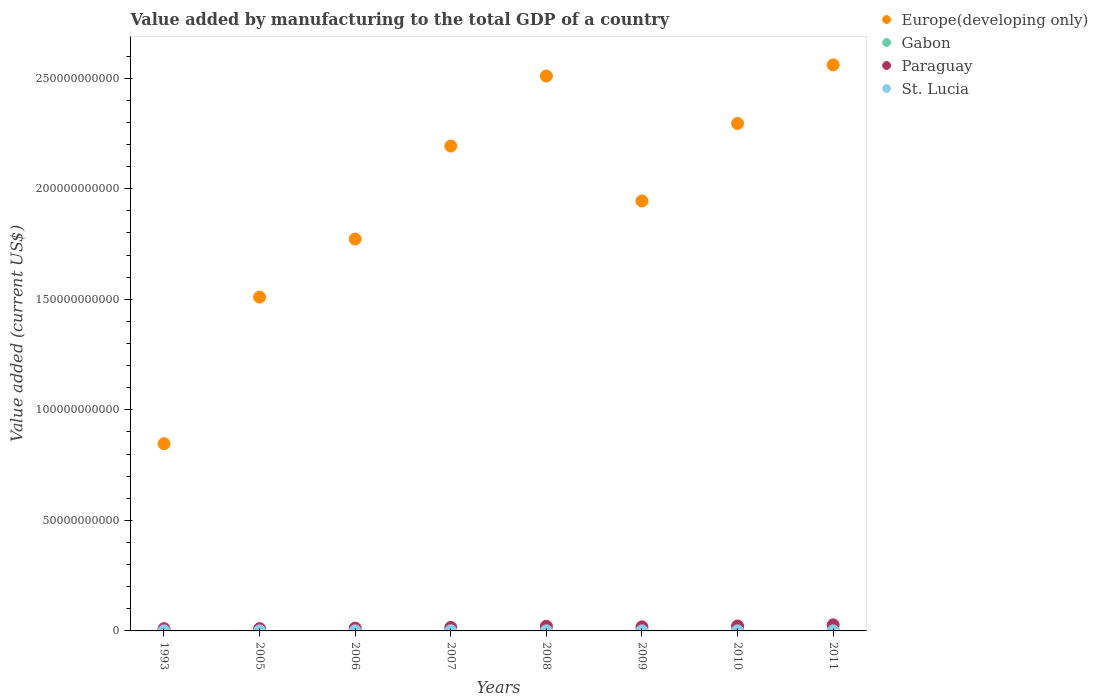How many different coloured dotlines are there?
Make the answer very short. 4. What is the value added by manufacturing to the total GDP in Europe(developing only) in 2006?
Your answer should be very brief. 1.77e+11. Across all years, what is the maximum value added by manufacturing to the total GDP in Paraguay?
Provide a succinct answer. 2.75e+09. Across all years, what is the minimum value added by manufacturing to the total GDP in Europe(developing only)?
Your answer should be compact. 8.47e+1. What is the total value added by manufacturing to the total GDP in Gabon in the graph?
Keep it short and to the point. 2.46e+09. What is the difference between the value added by manufacturing to the total GDP in Europe(developing only) in 1993 and that in 2006?
Offer a very short reply. -9.26e+1. What is the difference between the value added by manufacturing to the total GDP in Paraguay in 1993 and the value added by manufacturing to the total GDP in Gabon in 2009?
Offer a terse response. 6.67e+08. What is the average value added by manufacturing to the total GDP in Paraguay per year?
Ensure brevity in your answer.  1.73e+09. In the year 2011, what is the difference between the value added by manufacturing to the total GDP in Gabon and value added by manufacturing to the total GDP in St. Lucia?
Provide a succinct answer. 3.57e+08. What is the ratio of the value added by manufacturing to the total GDP in St. Lucia in 2006 to that in 2010?
Your response must be concise. 1.17. Is the value added by manufacturing to the total GDP in Gabon in 2006 less than that in 2007?
Your answer should be very brief. Yes. Is the difference between the value added by manufacturing to the total GDP in Gabon in 1993 and 2005 greater than the difference between the value added by manufacturing to the total GDP in St. Lucia in 1993 and 2005?
Your answer should be compact. Yes. What is the difference between the highest and the second highest value added by manufacturing to the total GDP in Europe(developing only)?
Provide a succinct answer. 5.05e+09. What is the difference between the highest and the lowest value added by manufacturing to the total GDP in Gabon?
Offer a very short reply. 1.70e+08. In how many years, is the value added by manufacturing to the total GDP in Paraguay greater than the average value added by manufacturing to the total GDP in Paraguay taken over all years?
Ensure brevity in your answer.  4. Is the sum of the value added by manufacturing to the total GDP in Paraguay in 1993 and 2011 greater than the maximum value added by manufacturing to the total GDP in Gabon across all years?
Ensure brevity in your answer.  Yes. Is it the case that in every year, the sum of the value added by manufacturing to the total GDP in Paraguay and value added by manufacturing to the total GDP in Europe(developing only)  is greater than the sum of value added by manufacturing to the total GDP in Gabon and value added by manufacturing to the total GDP in St. Lucia?
Make the answer very short. Yes. Does the value added by manufacturing to the total GDP in St. Lucia monotonically increase over the years?
Your answer should be compact. No. Is the value added by manufacturing to the total GDP in Europe(developing only) strictly less than the value added by manufacturing to the total GDP in Gabon over the years?
Ensure brevity in your answer.  No. How many dotlines are there?
Provide a succinct answer. 4. How many years are there in the graph?
Keep it short and to the point. 8. What is the difference between two consecutive major ticks on the Y-axis?
Offer a very short reply. 5.00e+1. Does the graph contain any zero values?
Offer a terse response. No. Does the graph contain grids?
Provide a short and direct response. No. Where does the legend appear in the graph?
Give a very brief answer. Top right. What is the title of the graph?
Offer a terse response. Value added by manufacturing to the total GDP of a country. Does "Sierra Leone" appear as one of the legend labels in the graph?
Your response must be concise. No. What is the label or title of the X-axis?
Offer a terse response. Years. What is the label or title of the Y-axis?
Provide a short and direct response. Value added (current US$). What is the Value added (current US$) of Europe(developing only) in 1993?
Offer a very short reply. 8.47e+1. What is the Value added (current US$) of Gabon in 1993?
Ensure brevity in your answer.  2.76e+08. What is the Value added (current US$) of Paraguay in 1993?
Offer a terse response. 1.01e+09. What is the Value added (current US$) in St. Lucia in 1993?
Your response must be concise. 3.07e+07. What is the Value added (current US$) of Europe(developing only) in 2005?
Provide a short and direct response. 1.51e+11. What is the Value added (current US$) in Gabon in 2005?
Your response must be concise. 2.28e+08. What is the Value added (current US$) of Paraguay in 2005?
Make the answer very short. 1.04e+09. What is the Value added (current US$) of St. Lucia in 2005?
Make the answer very short. 4.21e+07. What is the Value added (current US$) in Europe(developing only) in 2006?
Make the answer very short. 1.77e+11. What is the Value added (current US$) of Gabon in 2006?
Provide a succinct answer. 2.65e+08. What is the Value added (current US$) in Paraguay in 2006?
Give a very brief answer. 1.27e+09. What is the Value added (current US$) in St. Lucia in 2006?
Your answer should be very brief. 4.49e+07. What is the Value added (current US$) in Europe(developing only) in 2007?
Provide a succinct answer. 2.19e+11. What is the Value added (current US$) of Gabon in 2007?
Your response must be concise. 3.14e+08. What is the Value added (current US$) in Paraguay in 2007?
Your answer should be compact. 1.57e+09. What is the Value added (current US$) of St. Lucia in 2007?
Keep it short and to the point. 4.93e+07. What is the Value added (current US$) in Europe(developing only) in 2008?
Your answer should be compact. 2.51e+11. What is the Value added (current US$) of Gabon in 2008?
Your answer should be very brief. 3.51e+08. What is the Value added (current US$) of Paraguay in 2008?
Ensure brevity in your answer.  2.12e+09. What is the Value added (current US$) in St. Lucia in 2008?
Offer a terse response. 4.46e+07. What is the Value added (current US$) in Europe(developing only) in 2009?
Provide a succinct answer. 1.94e+11. What is the Value added (current US$) in Gabon in 2009?
Provide a short and direct response. 3.47e+08. What is the Value added (current US$) in Paraguay in 2009?
Ensure brevity in your answer.  1.85e+09. What is the Value added (current US$) of St. Lucia in 2009?
Offer a terse response. 4.00e+07. What is the Value added (current US$) of Europe(developing only) in 2010?
Give a very brief answer. 2.30e+11. What is the Value added (current US$) of Gabon in 2010?
Give a very brief answer. 2.79e+08. What is the Value added (current US$) in Paraguay in 2010?
Offer a terse response. 2.24e+09. What is the Value added (current US$) in St. Lucia in 2010?
Offer a terse response. 3.83e+07. What is the Value added (current US$) of Europe(developing only) in 2011?
Give a very brief answer. 2.56e+11. What is the Value added (current US$) in Gabon in 2011?
Your answer should be very brief. 3.98e+08. What is the Value added (current US$) of Paraguay in 2011?
Give a very brief answer. 2.75e+09. What is the Value added (current US$) of St. Lucia in 2011?
Make the answer very short. 4.11e+07. Across all years, what is the maximum Value added (current US$) in Europe(developing only)?
Your answer should be compact. 2.56e+11. Across all years, what is the maximum Value added (current US$) of Gabon?
Give a very brief answer. 3.98e+08. Across all years, what is the maximum Value added (current US$) in Paraguay?
Keep it short and to the point. 2.75e+09. Across all years, what is the maximum Value added (current US$) in St. Lucia?
Provide a short and direct response. 4.93e+07. Across all years, what is the minimum Value added (current US$) of Europe(developing only)?
Ensure brevity in your answer.  8.47e+1. Across all years, what is the minimum Value added (current US$) of Gabon?
Your response must be concise. 2.28e+08. Across all years, what is the minimum Value added (current US$) in Paraguay?
Give a very brief answer. 1.01e+09. Across all years, what is the minimum Value added (current US$) of St. Lucia?
Ensure brevity in your answer.  3.07e+07. What is the total Value added (current US$) in Europe(developing only) in the graph?
Your answer should be compact. 1.56e+12. What is the total Value added (current US$) in Gabon in the graph?
Your answer should be compact. 2.46e+09. What is the total Value added (current US$) of Paraguay in the graph?
Your answer should be compact. 1.38e+1. What is the total Value added (current US$) in St. Lucia in the graph?
Ensure brevity in your answer.  3.31e+08. What is the difference between the Value added (current US$) of Europe(developing only) in 1993 and that in 2005?
Your answer should be very brief. -6.63e+1. What is the difference between the Value added (current US$) of Gabon in 1993 and that in 2005?
Keep it short and to the point. 4.79e+07. What is the difference between the Value added (current US$) of Paraguay in 1993 and that in 2005?
Keep it short and to the point. -2.43e+07. What is the difference between the Value added (current US$) in St. Lucia in 1993 and that in 2005?
Make the answer very short. -1.14e+07. What is the difference between the Value added (current US$) of Europe(developing only) in 1993 and that in 2006?
Your answer should be very brief. -9.26e+1. What is the difference between the Value added (current US$) of Gabon in 1993 and that in 2006?
Your answer should be very brief. 1.08e+07. What is the difference between the Value added (current US$) of Paraguay in 1993 and that in 2006?
Provide a succinct answer. -2.53e+08. What is the difference between the Value added (current US$) in St. Lucia in 1993 and that in 2006?
Offer a terse response. -1.42e+07. What is the difference between the Value added (current US$) in Europe(developing only) in 1993 and that in 2007?
Provide a succinct answer. -1.35e+11. What is the difference between the Value added (current US$) in Gabon in 1993 and that in 2007?
Your answer should be very brief. -3.86e+07. What is the difference between the Value added (current US$) in Paraguay in 1993 and that in 2007?
Ensure brevity in your answer.  -5.56e+08. What is the difference between the Value added (current US$) of St. Lucia in 1993 and that in 2007?
Your answer should be compact. -1.85e+07. What is the difference between the Value added (current US$) in Europe(developing only) in 1993 and that in 2008?
Give a very brief answer. -1.66e+11. What is the difference between the Value added (current US$) in Gabon in 1993 and that in 2008?
Your answer should be very brief. -7.50e+07. What is the difference between the Value added (current US$) in Paraguay in 1993 and that in 2008?
Provide a short and direct response. -1.10e+09. What is the difference between the Value added (current US$) in St. Lucia in 1993 and that in 2008?
Provide a succinct answer. -1.39e+07. What is the difference between the Value added (current US$) of Europe(developing only) in 1993 and that in 2009?
Provide a succinct answer. -1.10e+11. What is the difference between the Value added (current US$) of Gabon in 1993 and that in 2009?
Provide a short and direct response. -7.19e+07. What is the difference between the Value added (current US$) in Paraguay in 1993 and that in 2009?
Make the answer very short. -8.36e+08. What is the difference between the Value added (current US$) of St. Lucia in 1993 and that in 2009?
Offer a very short reply. -9.31e+06. What is the difference between the Value added (current US$) in Europe(developing only) in 1993 and that in 2010?
Offer a terse response. -1.45e+11. What is the difference between the Value added (current US$) of Gabon in 1993 and that in 2010?
Your response must be concise. -3.63e+06. What is the difference between the Value added (current US$) of Paraguay in 1993 and that in 2010?
Offer a terse response. -1.23e+09. What is the difference between the Value added (current US$) in St. Lucia in 1993 and that in 2010?
Provide a succinct answer. -7.61e+06. What is the difference between the Value added (current US$) in Europe(developing only) in 1993 and that in 2011?
Give a very brief answer. -1.71e+11. What is the difference between the Value added (current US$) in Gabon in 1993 and that in 2011?
Provide a short and direct response. -1.22e+08. What is the difference between the Value added (current US$) of Paraguay in 1993 and that in 2011?
Provide a succinct answer. -1.74e+09. What is the difference between the Value added (current US$) of St. Lucia in 1993 and that in 2011?
Your answer should be very brief. -1.03e+07. What is the difference between the Value added (current US$) of Europe(developing only) in 2005 and that in 2006?
Your response must be concise. -2.63e+1. What is the difference between the Value added (current US$) in Gabon in 2005 and that in 2006?
Offer a very short reply. -3.71e+07. What is the difference between the Value added (current US$) in Paraguay in 2005 and that in 2006?
Ensure brevity in your answer.  -2.29e+08. What is the difference between the Value added (current US$) in St. Lucia in 2005 and that in 2006?
Give a very brief answer. -2.80e+06. What is the difference between the Value added (current US$) in Europe(developing only) in 2005 and that in 2007?
Give a very brief answer. -6.83e+1. What is the difference between the Value added (current US$) in Gabon in 2005 and that in 2007?
Provide a succinct answer. -8.66e+07. What is the difference between the Value added (current US$) in Paraguay in 2005 and that in 2007?
Ensure brevity in your answer.  -5.32e+08. What is the difference between the Value added (current US$) in St. Lucia in 2005 and that in 2007?
Offer a very short reply. -7.16e+06. What is the difference between the Value added (current US$) in Europe(developing only) in 2005 and that in 2008?
Offer a terse response. -1.00e+11. What is the difference between the Value added (current US$) in Gabon in 2005 and that in 2008?
Provide a short and direct response. -1.23e+08. What is the difference between the Value added (current US$) in Paraguay in 2005 and that in 2008?
Your response must be concise. -1.08e+09. What is the difference between the Value added (current US$) of St. Lucia in 2005 and that in 2008?
Your response must be concise. -2.50e+06. What is the difference between the Value added (current US$) of Europe(developing only) in 2005 and that in 2009?
Provide a short and direct response. -4.35e+1. What is the difference between the Value added (current US$) of Gabon in 2005 and that in 2009?
Your response must be concise. -1.20e+08. What is the difference between the Value added (current US$) of Paraguay in 2005 and that in 2009?
Make the answer very short. -8.11e+08. What is the difference between the Value added (current US$) in St. Lucia in 2005 and that in 2009?
Offer a very short reply. 2.07e+06. What is the difference between the Value added (current US$) of Europe(developing only) in 2005 and that in 2010?
Make the answer very short. -7.85e+1. What is the difference between the Value added (current US$) in Gabon in 2005 and that in 2010?
Keep it short and to the point. -5.16e+07. What is the difference between the Value added (current US$) of Paraguay in 2005 and that in 2010?
Ensure brevity in your answer.  -1.20e+09. What is the difference between the Value added (current US$) of St. Lucia in 2005 and that in 2010?
Make the answer very short. 3.77e+06. What is the difference between the Value added (current US$) of Europe(developing only) in 2005 and that in 2011?
Your response must be concise. -1.05e+11. What is the difference between the Value added (current US$) in Gabon in 2005 and that in 2011?
Your answer should be very brief. -1.70e+08. What is the difference between the Value added (current US$) of Paraguay in 2005 and that in 2011?
Give a very brief answer. -1.71e+09. What is the difference between the Value added (current US$) in St. Lucia in 2005 and that in 2011?
Your answer should be compact. 1.05e+06. What is the difference between the Value added (current US$) in Europe(developing only) in 2006 and that in 2007?
Your answer should be very brief. -4.21e+1. What is the difference between the Value added (current US$) in Gabon in 2006 and that in 2007?
Keep it short and to the point. -4.94e+07. What is the difference between the Value added (current US$) in Paraguay in 2006 and that in 2007?
Your answer should be very brief. -3.03e+08. What is the difference between the Value added (current US$) in St. Lucia in 2006 and that in 2007?
Keep it short and to the point. -4.36e+06. What is the difference between the Value added (current US$) of Europe(developing only) in 2006 and that in 2008?
Provide a short and direct response. -7.37e+1. What is the difference between the Value added (current US$) of Gabon in 2006 and that in 2008?
Offer a very short reply. -8.58e+07. What is the difference between the Value added (current US$) of Paraguay in 2006 and that in 2008?
Offer a very short reply. -8.51e+08. What is the difference between the Value added (current US$) in St. Lucia in 2006 and that in 2008?
Your response must be concise. 2.95e+05. What is the difference between the Value added (current US$) of Europe(developing only) in 2006 and that in 2009?
Your answer should be compact. -1.72e+1. What is the difference between the Value added (current US$) of Gabon in 2006 and that in 2009?
Your response must be concise. -8.27e+07. What is the difference between the Value added (current US$) in Paraguay in 2006 and that in 2009?
Make the answer very short. -5.83e+08. What is the difference between the Value added (current US$) in St. Lucia in 2006 and that in 2009?
Offer a very short reply. 4.86e+06. What is the difference between the Value added (current US$) of Europe(developing only) in 2006 and that in 2010?
Ensure brevity in your answer.  -5.23e+1. What is the difference between the Value added (current US$) of Gabon in 2006 and that in 2010?
Make the answer very short. -1.44e+07. What is the difference between the Value added (current US$) in Paraguay in 2006 and that in 2010?
Your answer should be compact. -9.72e+08. What is the difference between the Value added (current US$) in St. Lucia in 2006 and that in 2010?
Provide a succinct answer. 6.57e+06. What is the difference between the Value added (current US$) in Europe(developing only) in 2006 and that in 2011?
Provide a succinct answer. -7.88e+1. What is the difference between the Value added (current US$) in Gabon in 2006 and that in 2011?
Keep it short and to the point. -1.33e+08. What is the difference between the Value added (current US$) in Paraguay in 2006 and that in 2011?
Ensure brevity in your answer.  -1.48e+09. What is the difference between the Value added (current US$) of St. Lucia in 2006 and that in 2011?
Ensure brevity in your answer.  3.84e+06. What is the difference between the Value added (current US$) in Europe(developing only) in 2007 and that in 2008?
Provide a succinct answer. -3.17e+1. What is the difference between the Value added (current US$) of Gabon in 2007 and that in 2008?
Give a very brief answer. -3.64e+07. What is the difference between the Value added (current US$) of Paraguay in 2007 and that in 2008?
Your response must be concise. -5.48e+08. What is the difference between the Value added (current US$) of St. Lucia in 2007 and that in 2008?
Your response must be concise. 4.66e+06. What is the difference between the Value added (current US$) of Europe(developing only) in 2007 and that in 2009?
Your answer should be very brief. 2.48e+1. What is the difference between the Value added (current US$) of Gabon in 2007 and that in 2009?
Provide a short and direct response. -3.33e+07. What is the difference between the Value added (current US$) in Paraguay in 2007 and that in 2009?
Keep it short and to the point. -2.80e+08. What is the difference between the Value added (current US$) in St. Lucia in 2007 and that in 2009?
Make the answer very short. 9.22e+06. What is the difference between the Value added (current US$) in Europe(developing only) in 2007 and that in 2010?
Your response must be concise. -1.02e+1. What is the difference between the Value added (current US$) in Gabon in 2007 and that in 2010?
Give a very brief answer. 3.50e+07. What is the difference between the Value added (current US$) of Paraguay in 2007 and that in 2010?
Give a very brief answer. -6.70e+08. What is the difference between the Value added (current US$) of St. Lucia in 2007 and that in 2010?
Provide a short and direct response. 1.09e+07. What is the difference between the Value added (current US$) in Europe(developing only) in 2007 and that in 2011?
Make the answer very short. -3.67e+1. What is the difference between the Value added (current US$) of Gabon in 2007 and that in 2011?
Your response must be concise. -8.36e+07. What is the difference between the Value added (current US$) in Paraguay in 2007 and that in 2011?
Keep it short and to the point. -1.18e+09. What is the difference between the Value added (current US$) in St. Lucia in 2007 and that in 2011?
Your answer should be compact. 8.20e+06. What is the difference between the Value added (current US$) in Europe(developing only) in 2008 and that in 2009?
Offer a very short reply. 5.65e+1. What is the difference between the Value added (current US$) of Gabon in 2008 and that in 2009?
Provide a succinct answer. 3.14e+06. What is the difference between the Value added (current US$) in Paraguay in 2008 and that in 2009?
Give a very brief answer. 2.68e+08. What is the difference between the Value added (current US$) of St. Lucia in 2008 and that in 2009?
Provide a succinct answer. 4.57e+06. What is the difference between the Value added (current US$) of Europe(developing only) in 2008 and that in 2010?
Your answer should be compact. 2.15e+1. What is the difference between the Value added (current US$) of Gabon in 2008 and that in 2010?
Provide a short and direct response. 7.14e+07. What is the difference between the Value added (current US$) of Paraguay in 2008 and that in 2010?
Provide a short and direct response. -1.21e+08. What is the difference between the Value added (current US$) of St. Lucia in 2008 and that in 2010?
Keep it short and to the point. 6.27e+06. What is the difference between the Value added (current US$) of Europe(developing only) in 2008 and that in 2011?
Make the answer very short. -5.05e+09. What is the difference between the Value added (current US$) in Gabon in 2008 and that in 2011?
Ensure brevity in your answer.  -4.72e+07. What is the difference between the Value added (current US$) of Paraguay in 2008 and that in 2011?
Offer a terse response. -6.31e+08. What is the difference between the Value added (current US$) in St. Lucia in 2008 and that in 2011?
Ensure brevity in your answer.  3.55e+06. What is the difference between the Value added (current US$) in Europe(developing only) in 2009 and that in 2010?
Provide a succinct answer. -3.51e+1. What is the difference between the Value added (current US$) in Gabon in 2009 and that in 2010?
Your response must be concise. 6.83e+07. What is the difference between the Value added (current US$) in Paraguay in 2009 and that in 2010?
Keep it short and to the point. -3.90e+08. What is the difference between the Value added (current US$) in St. Lucia in 2009 and that in 2010?
Provide a short and direct response. 1.70e+06. What is the difference between the Value added (current US$) of Europe(developing only) in 2009 and that in 2011?
Make the answer very short. -6.16e+1. What is the difference between the Value added (current US$) of Gabon in 2009 and that in 2011?
Ensure brevity in your answer.  -5.03e+07. What is the difference between the Value added (current US$) of Paraguay in 2009 and that in 2011?
Offer a terse response. -8.99e+08. What is the difference between the Value added (current US$) of St. Lucia in 2009 and that in 2011?
Provide a short and direct response. -1.02e+06. What is the difference between the Value added (current US$) of Europe(developing only) in 2010 and that in 2011?
Give a very brief answer. -2.65e+1. What is the difference between the Value added (current US$) of Gabon in 2010 and that in 2011?
Offer a very short reply. -1.19e+08. What is the difference between the Value added (current US$) in Paraguay in 2010 and that in 2011?
Ensure brevity in your answer.  -5.10e+08. What is the difference between the Value added (current US$) of St. Lucia in 2010 and that in 2011?
Your answer should be compact. -2.72e+06. What is the difference between the Value added (current US$) of Europe(developing only) in 1993 and the Value added (current US$) of Gabon in 2005?
Offer a very short reply. 8.44e+1. What is the difference between the Value added (current US$) of Europe(developing only) in 1993 and the Value added (current US$) of Paraguay in 2005?
Your answer should be compact. 8.36e+1. What is the difference between the Value added (current US$) of Europe(developing only) in 1993 and the Value added (current US$) of St. Lucia in 2005?
Keep it short and to the point. 8.46e+1. What is the difference between the Value added (current US$) of Gabon in 1993 and the Value added (current US$) of Paraguay in 2005?
Provide a short and direct response. -7.63e+08. What is the difference between the Value added (current US$) of Gabon in 1993 and the Value added (current US$) of St. Lucia in 2005?
Make the answer very short. 2.33e+08. What is the difference between the Value added (current US$) of Paraguay in 1993 and the Value added (current US$) of St. Lucia in 2005?
Provide a succinct answer. 9.72e+08. What is the difference between the Value added (current US$) in Europe(developing only) in 1993 and the Value added (current US$) in Gabon in 2006?
Your answer should be very brief. 8.44e+1. What is the difference between the Value added (current US$) in Europe(developing only) in 1993 and the Value added (current US$) in Paraguay in 2006?
Ensure brevity in your answer.  8.34e+1. What is the difference between the Value added (current US$) in Europe(developing only) in 1993 and the Value added (current US$) in St. Lucia in 2006?
Keep it short and to the point. 8.46e+1. What is the difference between the Value added (current US$) of Gabon in 1993 and the Value added (current US$) of Paraguay in 2006?
Your answer should be very brief. -9.92e+08. What is the difference between the Value added (current US$) in Gabon in 1993 and the Value added (current US$) in St. Lucia in 2006?
Offer a very short reply. 2.31e+08. What is the difference between the Value added (current US$) of Paraguay in 1993 and the Value added (current US$) of St. Lucia in 2006?
Your answer should be compact. 9.69e+08. What is the difference between the Value added (current US$) of Europe(developing only) in 1993 and the Value added (current US$) of Gabon in 2007?
Make the answer very short. 8.44e+1. What is the difference between the Value added (current US$) in Europe(developing only) in 1993 and the Value added (current US$) in Paraguay in 2007?
Your answer should be compact. 8.31e+1. What is the difference between the Value added (current US$) in Europe(developing only) in 1993 and the Value added (current US$) in St. Lucia in 2007?
Offer a terse response. 8.46e+1. What is the difference between the Value added (current US$) of Gabon in 1993 and the Value added (current US$) of Paraguay in 2007?
Offer a very short reply. -1.29e+09. What is the difference between the Value added (current US$) in Gabon in 1993 and the Value added (current US$) in St. Lucia in 2007?
Your answer should be very brief. 2.26e+08. What is the difference between the Value added (current US$) in Paraguay in 1993 and the Value added (current US$) in St. Lucia in 2007?
Ensure brevity in your answer.  9.65e+08. What is the difference between the Value added (current US$) of Europe(developing only) in 1993 and the Value added (current US$) of Gabon in 2008?
Make the answer very short. 8.43e+1. What is the difference between the Value added (current US$) in Europe(developing only) in 1993 and the Value added (current US$) in Paraguay in 2008?
Offer a terse response. 8.26e+1. What is the difference between the Value added (current US$) of Europe(developing only) in 1993 and the Value added (current US$) of St. Lucia in 2008?
Provide a succinct answer. 8.46e+1. What is the difference between the Value added (current US$) in Gabon in 1993 and the Value added (current US$) in Paraguay in 2008?
Your answer should be compact. -1.84e+09. What is the difference between the Value added (current US$) of Gabon in 1993 and the Value added (current US$) of St. Lucia in 2008?
Your response must be concise. 2.31e+08. What is the difference between the Value added (current US$) in Paraguay in 1993 and the Value added (current US$) in St. Lucia in 2008?
Offer a very short reply. 9.69e+08. What is the difference between the Value added (current US$) in Europe(developing only) in 1993 and the Value added (current US$) in Gabon in 2009?
Provide a short and direct response. 8.43e+1. What is the difference between the Value added (current US$) of Europe(developing only) in 1993 and the Value added (current US$) of Paraguay in 2009?
Your answer should be compact. 8.28e+1. What is the difference between the Value added (current US$) in Europe(developing only) in 1993 and the Value added (current US$) in St. Lucia in 2009?
Offer a very short reply. 8.46e+1. What is the difference between the Value added (current US$) of Gabon in 1993 and the Value added (current US$) of Paraguay in 2009?
Offer a terse response. -1.57e+09. What is the difference between the Value added (current US$) of Gabon in 1993 and the Value added (current US$) of St. Lucia in 2009?
Offer a terse response. 2.35e+08. What is the difference between the Value added (current US$) of Paraguay in 1993 and the Value added (current US$) of St. Lucia in 2009?
Give a very brief answer. 9.74e+08. What is the difference between the Value added (current US$) of Europe(developing only) in 1993 and the Value added (current US$) of Gabon in 2010?
Offer a terse response. 8.44e+1. What is the difference between the Value added (current US$) in Europe(developing only) in 1993 and the Value added (current US$) in Paraguay in 2010?
Keep it short and to the point. 8.24e+1. What is the difference between the Value added (current US$) of Europe(developing only) in 1993 and the Value added (current US$) of St. Lucia in 2010?
Give a very brief answer. 8.46e+1. What is the difference between the Value added (current US$) in Gabon in 1993 and the Value added (current US$) in Paraguay in 2010?
Provide a short and direct response. -1.96e+09. What is the difference between the Value added (current US$) in Gabon in 1993 and the Value added (current US$) in St. Lucia in 2010?
Ensure brevity in your answer.  2.37e+08. What is the difference between the Value added (current US$) in Paraguay in 1993 and the Value added (current US$) in St. Lucia in 2010?
Provide a short and direct response. 9.76e+08. What is the difference between the Value added (current US$) in Europe(developing only) in 1993 and the Value added (current US$) in Gabon in 2011?
Your answer should be very brief. 8.43e+1. What is the difference between the Value added (current US$) of Europe(developing only) in 1993 and the Value added (current US$) of Paraguay in 2011?
Your answer should be very brief. 8.19e+1. What is the difference between the Value added (current US$) in Europe(developing only) in 1993 and the Value added (current US$) in St. Lucia in 2011?
Ensure brevity in your answer.  8.46e+1. What is the difference between the Value added (current US$) of Gabon in 1993 and the Value added (current US$) of Paraguay in 2011?
Your answer should be compact. -2.47e+09. What is the difference between the Value added (current US$) of Gabon in 1993 and the Value added (current US$) of St. Lucia in 2011?
Offer a terse response. 2.34e+08. What is the difference between the Value added (current US$) of Paraguay in 1993 and the Value added (current US$) of St. Lucia in 2011?
Your answer should be compact. 9.73e+08. What is the difference between the Value added (current US$) of Europe(developing only) in 2005 and the Value added (current US$) of Gabon in 2006?
Give a very brief answer. 1.51e+11. What is the difference between the Value added (current US$) of Europe(developing only) in 2005 and the Value added (current US$) of Paraguay in 2006?
Offer a terse response. 1.50e+11. What is the difference between the Value added (current US$) of Europe(developing only) in 2005 and the Value added (current US$) of St. Lucia in 2006?
Your answer should be compact. 1.51e+11. What is the difference between the Value added (current US$) in Gabon in 2005 and the Value added (current US$) in Paraguay in 2006?
Offer a terse response. -1.04e+09. What is the difference between the Value added (current US$) of Gabon in 2005 and the Value added (current US$) of St. Lucia in 2006?
Offer a very short reply. 1.83e+08. What is the difference between the Value added (current US$) of Paraguay in 2005 and the Value added (current US$) of St. Lucia in 2006?
Make the answer very short. 9.93e+08. What is the difference between the Value added (current US$) of Europe(developing only) in 2005 and the Value added (current US$) of Gabon in 2007?
Your response must be concise. 1.51e+11. What is the difference between the Value added (current US$) of Europe(developing only) in 2005 and the Value added (current US$) of Paraguay in 2007?
Your answer should be very brief. 1.49e+11. What is the difference between the Value added (current US$) in Europe(developing only) in 2005 and the Value added (current US$) in St. Lucia in 2007?
Give a very brief answer. 1.51e+11. What is the difference between the Value added (current US$) in Gabon in 2005 and the Value added (current US$) in Paraguay in 2007?
Make the answer very short. -1.34e+09. What is the difference between the Value added (current US$) in Gabon in 2005 and the Value added (current US$) in St. Lucia in 2007?
Offer a very short reply. 1.78e+08. What is the difference between the Value added (current US$) of Paraguay in 2005 and the Value added (current US$) of St. Lucia in 2007?
Provide a short and direct response. 9.89e+08. What is the difference between the Value added (current US$) of Europe(developing only) in 2005 and the Value added (current US$) of Gabon in 2008?
Provide a succinct answer. 1.51e+11. What is the difference between the Value added (current US$) in Europe(developing only) in 2005 and the Value added (current US$) in Paraguay in 2008?
Your response must be concise. 1.49e+11. What is the difference between the Value added (current US$) of Europe(developing only) in 2005 and the Value added (current US$) of St. Lucia in 2008?
Give a very brief answer. 1.51e+11. What is the difference between the Value added (current US$) in Gabon in 2005 and the Value added (current US$) in Paraguay in 2008?
Offer a very short reply. -1.89e+09. What is the difference between the Value added (current US$) in Gabon in 2005 and the Value added (current US$) in St. Lucia in 2008?
Provide a short and direct response. 1.83e+08. What is the difference between the Value added (current US$) of Paraguay in 2005 and the Value added (current US$) of St. Lucia in 2008?
Your answer should be very brief. 9.94e+08. What is the difference between the Value added (current US$) of Europe(developing only) in 2005 and the Value added (current US$) of Gabon in 2009?
Provide a succinct answer. 1.51e+11. What is the difference between the Value added (current US$) of Europe(developing only) in 2005 and the Value added (current US$) of Paraguay in 2009?
Provide a succinct answer. 1.49e+11. What is the difference between the Value added (current US$) in Europe(developing only) in 2005 and the Value added (current US$) in St. Lucia in 2009?
Give a very brief answer. 1.51e+11. What is the difference between the Value added (current US$) of Gabon in 2005 and the Value added (current US$) of Paraguay in 2009?
Offer a terse response. -1.62e+09. What is the difference between the Value added (current US$) in Gabon in 2005 and the Value added (current US$) in St. Lucia in 2009?
Offer a very short reply. 1.88e+08. What is the difference between the Value added (current US$) in Paraguay in 2005 and the Value added (current US$) in St. Lucia in 2009?
Keep it short and to the point. 9.98e+08. What is the difference between the Value added (current US$) in Europe(developing only) in 2005 and the Value added (current US$) in Gabon in 2010?
Offer a very short reply. 1.51e+11. What is the difference between the Value added (current US$) in Europe(developing only) in 2005 and the Value added (current US$) in Paraguay in 2010?
Ensure brevity in your answer.  1.49e+11. What is the difference between the Value added (current US$) of Europe(developing only) in 2005 and the Value added (current US$) of St. Lucia in 2010?
Provide a short and direct response. 1.51e+11. What is the difference between the Value added (current US$) of Gabon in 2005 and the Value added (current US$) of Paraguay in 2010?
Keep it short and to the point. -2.01e+09. What is the difference between the Value added (current US$) in Gabon in 2005 and the Value added (current US$) in St. Lucia in 2010?
Provide a short and direct response. 1.89e+08. What is the difference between the Value added (current US$) in Paraguay in 2005 and the Value added (current US$) in St. Lucia in 2010?
Provide a short and direct response. 1.00e+09. What is the difference between the Value added (current US$) of Europe(developing only) in 2005 and the Value added (current US$) of Gabon in 2011?
Make the answer very short. 1.51e+11. What is the difference between the Value added (current US$) in Europe(developing only) in 2005 and the Value added (current US$) in Paraguay in 2011?
Provide a succinct answer. 1.48e+11. What is the difference between the Value added (current US$) of Europe(developing only) in 2005 and the Value added (current US$) of St. Lucia in 2011?
Offer a terse response. 1.51e+11. What is the difference between the Value added (current US$) of Gabon in 2005 and the Value added (current US$) of Paraguay in 2011?
Offer a very short reply. -2.52e+09. What is the difference between the Value added (current US$) of Gabon in 2005 and the Value added (current US$) of St. Lucia in 2011?
Your response must be concise. 1.86e+08. What is the difference between the Value added (current US$) in Paraguay in 2005 and the Value added (current US$) in St. Lucia in 2011?
Your answer should be very brief. 9.97e+08. What is the difference between the Value added (current US$) in Europe(developing only) in 2006 and the Value added (current US$) in Gabon in 2007?
Provide a succinct answer. 1.77e+11. What is the difference between the Value added (current US$) in Europe(developing only) in 2006 and the Value added (current US$) in Paraguay in 2007?
Make the answer very short. 1.76e+11. What is the difference between the Value added (current US$) of Europe(developing only) in 2006 and the Value added (current US$) of St. Lucia in 2007?
Offer a terse response. 1.77e+11. What is the difference between the Value added (current US$) in Gabon in 2006 and the Value added (current US$) in Paraguay in 2007?
Offer a very short reply. -1.31e+09. What is the difference between the Value added (current US$) in Gabon in 2006 and the Value added (current US$) in St. Lucia in 2007?
Provide a short and direct response. 2.15e+08. What is the difference between the Value added (current US$) of Paraguay in 2006 and the Value added (current US$) of St. Lucia in 2007?
Your response must be concise. 1.22e+09. What is the difference between the Value added (current US$) in Europe(developing only) in 2006 and the Value added (current US$) in Gabon in 2008?
Give a very brief answer. 1.77e+11. What is the difference between the Value added (current US$) in Europe(developing only) in 2006 and the Value added (current US$) in Paraguay in 2008?
Offer a very short reply. 1.75e+11. What is the difference between the Value added (current US$) of Europe(developing only) in 2006 and the Value added (current US$) of St. Lucia in 2008?
Your response must be concise. 1.77e+11. What is the difference between the Value added (current US$) of Gabon in 2006 and the Value added (current US$) of Paraguay in 2008?
Offer a terse response. -1.85e+09. What is the difference between the Value added (current US$) of Gabon in 2006 and the Value added (current US$) of St. Lucia in 2008?
Your answer should be compact. 2.20e+08. What is the difference between the Value added (current US$) of Paraguay in 2006 and the Value added (current US$) of St. Lucia in 2008?
Ensure brevity in your answer.  1.22e+09. What is the difference between the Value added (current US$) of Europe(developing only) in 2006 and the Value added (current US$) of Gabon in 2009?
Provide a succinct answer. 1.77e+11. What is the difference between the Value added (current US$) of Europe(developing only) in 2006 and the Value added (current US$) of Paraguay in 2009?
Give a very brief answer. 1.75e+11. What is the difference between the Value added (current US$) in Europe(developing only) in 2006 and the Value added (current US$) in St. Lucia in 2009?
Make the answer very short. 1.77e+11. What is the difference between the Value added (current US$) in Gabon in 2006 and the Value added (current US$) in Paraguay in 2009?
Your response must be concise. -1.59e+09. What is the difference between the Value added (current US$) of Gabon in 2006 and the Value added (current US$) of St. Lucia in 2009?
Your response must be concise. 2.25e+08. What is the difference between the Value added (current US$) of Paraguay in 2006 and the Value added (current US$) of St. Lucia in 2009?
Your answer should be very brief. 1.23e+09. What is the difference between the Value added (current US$) in Europe(developing only) in 2006 and the Value added (current US$) in Gabon in 2010?
Your response must be concise. 1.77e+11. What is the difference between the Value added (current US$) of Europe(developing only) in 2006 and the Value added (current US$) of Paraguay in 2010?
Keep it short and to the point. 1.75e+11. What is the difference between the Value added (current US$) in Europe(developing only) in 2006 and the Value added (current US$) in St. Lucia in 2010?
Provide a succinct answer. 1.77e+11. What is the difference between the Value added (current US$) of Gabon in 2006 and the Value added (current US$) of Paraguay in 2010?
Ensure brevity in your answer.  -1.97e+09. What is the difference between the Value added (current US$) in Gabon in 2006 and the Value added (current US$) in St. Lucia in 2010?
Your response must be concise. 2.26e+08. What is the difference between the Value added (current US$) of Paraguay in 2006 and the Value added (current US$) of St. Lucia in 2010?
Your answer should be very brief. 1.23e+09. What is the difference between the Value added (current US$) of Europe(developing only) in 2006 and the Value added (current US$) of Gabon in 2011?
Make the answer very short. 1.77e+11. What is the difference between the Value added (current US$) in Europe(developing only) in 2006 and the Value added (current US$) in Paraguay in 2011?
Your answer should be compact. 1.74e+11. What is the difference between the Value added (current US$) in Europe(developing only) in 2006 and the Value added (current US$) in St. Lucia in 2011?
Your answer should be very brief. 1.77e+11. What is the difference between the Value added (current US$) of Gabon in 2006 and the Value added (current US$) of Paraguay in 2011?
Offer a terse response. -2.48e+09. What is the difference between the Value added (current US$) of Gabon in 2006 and the Value added (current US$) of St. Lucia in 2011?
Make the answer very short. 2.24e+08. What is the difference between the Value added (current US$) in Paraguay in 2006 and the Value added (current US$) in St. Lucia in 2011?
Provide a succinct answer. 1.23e+09. What is the difference between the Value added (current US$) in Europe(developing only) in 2007 and the Value added (current US$) in Gabon in 2008?
Your answer should be compact. 2.19e+11. What is the difference between the Value added (current US$) of Europe(developing only) in 2007 and the Value added (current US$) of Paraguay in 2008?
Your response must be concise. 2.17e+11. What is the difference between the Value added (current US$) in Europe(developing only) in 2007 and the Value added (current US$) in St. Lucia in 2008?
Make the answer very short. 2.19e+11. What is the difference between the Value added (current US$) in Gabon in 2007 and the Value added (current US$) in Paraguay in 2008?
Ensure brevity in your answer.  -1.80e+09. What is the difference between the Value added (current US$) of Gabon in 2007 and the Value added (current US$) of St. Lucia in 2008?
Offer a terse response. 2.70e+08. What is the difference between the Value added (current US$) of Paraguay in 2007 and the Value added (current US$) of St. Lucia in 2008?
Provide a short and direct response. 1.53e+09. What is the difference between the Value added (current US$) of Europe(developing only) in 2007 and the Value added (current US$) of Gabon in 2009?
Offer a very short reply. 2.19e+11. What is the difference between the Value added (current US$) in Europe(developing only) in 2007 and the Value added (current US$) in Paraguay in 2009?
Keep it short and to the point. 2.17e+11. What is the difference between the Value added (current US$) of Europe(developing only) in 2007 and the Value added (current US$) of St. Lucia in 2009?
Provide a succinct answer. 2.19e+11. What is the difference between the Value added (current US$) of Gabon in 2007 and the Value added (current US$) of Paraguay in 2009?
Make the answer very short. -1.54e+09. What is the difference between the Value added (current US$) of Gabon in 2007 and the Value added (current US$) of St. Lucia in 2009?
Provide a succinct answer. 2.74e+08. What is the difference between the Value added (current US$) of Paraguay in 2007 and the Value added (current US$) of St. Lucia in 2009?
Your response must be concise. 1.53e+09. What is the difference between the Value added (current US$) of Europe(developing only) in 2007 and the Value added (current US$) of Gabon in 2010?
Offer a very short reply. 2.19e+11. What is the difference between the Value added (current US$) in Europe(developing only) in 2007 and the Value added (current US$) in Paraguay in 2010?
Give a very brief answer. 2.17e+11. What is the difference between the Value added (current US$) in Europe(developing only) in 2007 and the Value added (current US$) in St. Lucia in 2010?
Your answer should be compact. 2.19e+11. What is the difference between the Value added (current US$) of Gabon in 2007 and the Value added (current US$) of Paraguay in 2010?
Ensure brevity in your answer.  -1.93e+09. What is the difference between the Value added (current US$) of Gabon in 2007 and the Value added (current US$) of St. Lucia in 2010?
Provide a succinct answer. 2.76e+08. What is the difference between the Value added (current US$) in Paraguay in 2007 and the Value added (current US$) in St. Lucia in 2010?
Your response must be concise. 1.53e+09. What is the difference between the Value added (current US$) in Europe(developing only) in 2007 and the Value added (current US$) in Gabon in 2011?
Give a very brief answer. 2.19e+11. What is the difference between the Value added (current US$) in Europe(developing only) in 2007 and the Value added (current US$) in Paraguay in 2011?
Offer a very short reply. 2.17e+11. What is the difference between the Value added (current US$) of Europe(developing only) in 2007 and the Value added (current US$) of St. Lucia in 2011?
Give a very brief answer. 2.19e+11. What is the difference between the Value added (current US$) in Gabon in 2007 and the Value added (current US$) in Paraguay in 2011?
Make the answer very short. -2.43e+09. What is the difference between the Value added (current US$) in Gabon in 2007 and the Value added (current US$) in St. Lucia in 2011?
Provide a succinct answer. 2.73e+08. What is the difference between the Value added (current US$) in Paraguay in 2007 and the Value added (current US$) in St. Lucia in 2011?
Your answer should be compact. 1.53e+09. What is the difference between the Value added (current US$) in Europe(developing only) in 2008 and the Value added (current US$) in Gabon in 2009?
Your answer should be compact. 2.51e+11. What is the difference between the Value added (current US$) in Europe(developing only) in 2008 and the Value added (current US$) in Paraguay in 2009?
Your answer should be very brief. 2.49e+11. What is the difference between the Value added (current US$) of Europe(developing only) in 2008 and the Value added (current US$) of St. Lucia in 2009?
Make the answer very short. 2.51e+11. What is the difference between the Value added (current US$) of Gabon in 2008 and the Value added (current US$) of Paraguay in 2009?
Make the answer very short. -1.50e+09. What is the difference between the Value added (current US$) in Gabon in 2008 and the Value added (current US$) in St. Lucia in 2009?
Offer a terse response. 3.10e+08. What is the difference between the Value added (current US$) in Paraguay in 2008 and the Value added (current US$) in St. Lucia in 2009?
Keep it short and to the point. 2.08e+09. What is the difference between the Value added (current US$) of Europe(developing only) in 2008 and the Value added (current US$) of Gabon in 2010?
Provide a short and direct response. 2.51e+11. What is the difference between the Value added (current US$) of Europe(developing only) in 2008 and the Value added (current US$) of Paraguay in 2010?
Make the answer very short. 2.49e+11. What is the difference between the Value added (current US$) of Europe(developing only) in 2008 and the Value added (current US$) of St. Lucia in 2010?
Provide a short and direct response. 2.51e+11. What is the difference between the Value added (current US$) in Gabon in 2008 and the Value added (current US$) in Paraguay in 2010?
Provide a succinct answer. -1.89e+09. What is the difference between the Value added (current US$) in Gabon in 2008 and the Value added (current US$) in St. Lucia in 2010?
Give a very brief answer. 3.12e+08. What is the difference between the Value added (current US$) in Paraguay in 2008 and the Value added (current US$) in St. Lucia in 2010?
Offer a very short reply. 2.08e+09. What is the difference between the Value added (current US$) in Europe(developing only) in 2008 and the Value added (current US$) in Gabon in 2011?
Your response must be concise. 2.51e+11. What is the difference between the Value added (current US$) of Europe(developing only) in 2008 and the Value added (current US$) of Paraguay in 2011?
Make the answer very short. 2.48e+11. What is the difference between the Value added (current US$) of Europe(developing only) in 2008 and the Value added (current US$) of St. Lucia in 2011?
Give a very brief answer. 2.51e+11. What is the difference between the Value added (current US$) in Gabon in 2008 and the Value added (current US$) in Paraguay in 2011?
Offer a very short reply. -2.40e+09. What is the difference between the Value added (current US$) of Gabon in 2008 and the Value added (current US$) of St. Lucia in 2011?
Offer a very short reply. 3.09e+08. What is the difference between the Value added (current US$) of Paraguay in 2008 and the Value added (current US$) of St. Lucia in 2011?
Keep it short and to the point. 2.08e+09. What is the difference between the Value added (current US$) in Europe(developing only) in 2009 and the Value added (current US$) in Gabon in 2010?
Your answer should be compact. 1.94e+11. What is the difference between the Value added (current US$) in Europe(developing only) in 2009 and the Value added (current US$) in Paraguay in 2010?
Offer a very short reply. 1.92e+11. What is the difference between the Value added (current US$) of Europe(developing only) in 2009 and the Value added (current US$) of St. Lucia in 2010?
Your answer should be very brief. 1.94e+11. What is the difference between the Value added (current US$) in Gabon in 2009 and the Value added (current US$) in Paraguay in 2010?
Offer a very short reply. -1.89e+09. What is the difference between the Value added (current US$) in Gabon in 2009 and the Value added (current US$) in St. Lucia in 2010?
Provide a succinct answer. 3.09e+08. What is the difference between the Value added (current US$) of Paraguay in 2009 and the Value added (current US$) of St. Lucia in 2010?
Ensure brevity in your answer.  1.81e+09. What is the difference between the Value added (current US$) in Europe(developing only) in 2009 and the Value added (current US$) in Gabon in 2011?
Offer a very short reply. 1.94e+11. What is the difference between the Value added (current US$) of Europe(developing only) in 2009 and the Value added (current US$) of Paraguay in 2011?
Your response must be concise. 1.92e+11. What is the difference between the Value added (current US$) in Europe(developing only) in 2009 and the Value added (current US$) in St. Lucia in 2011?
Your response must be concise. 1.94e+11. What is the difference between the Value added (current US$) in Gabon in 2009 and the Value added (current US$) in Paraguay in 2011?
Make the answer very short. -2.40e+09. What is the difference between the Value added (current US$) in Gabon in 2009 and the Value added (current US$) in St. Lucia in 2011?
Offer a very short reply. 3.06e+08. What is the difference between the Value added (current US$) in Paraguay in 2009 and the Value added (current US$) in St. Lucia in 2011?
Your answer should be very brief. 1.81e+09. What is the difference between the Value added (current US$) in Europe(developing only) in 2010 and the Value added (current US$) in Gabon in 2011?
Make the answer very short. 2.29e+11. What is the difference between the Value added (current US$) in Europe(developing only) in 2010 and the Value added (current US$) in Paraguay in 2011?
Offer a terse response. 2.27e+11. What is the difference between the Value added (current US$) in Europe(developing only) in 2010 and the Value added (current US$) in St. Lucia in 2011?
Your answer should be compact. 2.29e+11. What is the difference between the Value added (current US$) of Gabon in 2010 and the Value added (current US$) of Paraguay in 2011?
Keep it short and to the point. -2.47e+09. What is the difference between the Value added (current US$) of Gabon in 2010 and the Value added (current US$) of St. Lucia in 2011?
Keep it short and to the point. 2.38e+08. What is the difference between the Value added (current US$) in Paraguay in 2010 and the Value added (current US$) in St. Lucia in 2011?
Your answer should be compact. 2.20e+09. What is the average Value added (current US$) in Europe(developing only) per year?
Your answer should be compact. 1.95e+11. What is the average Value added (current US$) in Gabon per year?
Your answer should be very brief. 3.07e+08. What is the average Value added (current US$) in Paraguay per year?
Ensure brevity in your answer.  1.73e+09. What is the average Value added (current US$) in St. Lucia per year?
Keep it short and to the point. 4.14e+07. In the year 1993, what is the difference between the Value added (current US$) in Europe(developing only) and Value added (current US$) in Gabon?
Make the answer very short. 8.44e+1. In the year 1993, what is the difference between the Value added (current US$) in Europe(developing only) and Value added (current US$) in Paraguay?
Offer a very short reply. 8.37e+1. In the year 1993, what is the difference between the Value added (current US$) of Europe(developing only) and Value added (current US$) of St. Lucia?
Keep it short and to the point. 8.46e+1. In the year 1993, what is the difference between the Value added (current US$) of Gabon and Value added (current US$) of Paraguay?
Ensure brevity in your answer.  -7.39e+08. In the year 1993, what is the difference between the Value added (current US$) in Gabon and Value added (current US$) in St. Lucia?
Offer a terse response. 2.45e+08. In the year 1993, what is the difference between the Value added (current US$) in Paraguay and Value added (current US$) in St. Lucia?
Offer a terse response. 9.83e+08. In the year 2005, what is the difference between the Value added (current US$) in Europe(developing only) and Value added (current US$) in Gabon?
Provide a short and direct response. 1.51e+11. In the year 2005, what is the difference between the Value added (current US$) in Europe(developing only) and Value added (current US$) in Paraguay?
Your response must be concise. 1.50e+11. In the year 2005, what is the difference between the Value added (current US$) of Europe(developing only) and Value added (current US$) of St. Lucia?
Keep it short and to the point. 1.51e+11. In the year 2005, what is the difference between the Value added (current US$) in Gabon and Value added (current US$) in Paraguay?
Your answer should be very brief. -8.11e+08. In the year 2005, what is the difference between the Value added (current US$) in Gabon and Value added (current US$) in St. Lucia?
Your answer should be compact. 1.85e+08. In the year 2005, what is the difference between the Value added (current US$) of Paraguay and Value added (current US$) of St. Lucia?
Your answer should be compact. 9.96e+08. In the year 2006, what is the difference between the Value added (current US$) in Europe(developing only) and Value added (current US$) in Gabon?
Offer a terse response. 1.77e+11. In the year 2006, what is the difference between the Value added (current US$) of Europe(developing only) and Value added (current US$) of Paraguay?
Offer a terse response. 1.76e+11. In the year 2006, what is the difference between the Value added (current US$) in Europe(developing only) and Value added (current US$) in St. Lucia?
Provide a short and direct response. 1.77e+11. In the year 2006, what is the difference between the Value added (current US$) of Gabon and Value added (current US$) of Paraguay?
Provide a short and direct response. -1.00e+09. In the year 2006, what is the difference between the Value added (current US$) of Gabon and Value added (current US$) of St. Lucia?
Your response must be concise. 2.20e+08. In the year 2006, what is the difference between the Value added (current US$) in Paraguay and Value added (current US$) in St. Lucia?
Give a very brief answer. 1.22e+09. In the year 2007, what is the difference between the Value added (current US$) of Europe(developing only) and Value added (current US$) of Gabon?
Offer a terse response. 2.19e+11. In the year 2007, what is the difference between the Value added (current US$) in Europe(developing only) and Value added (current US$) in Paraguay?
Offer a very short reply. 2.18e+11. In the year 2007, what is the difference between the Value added (current US$) of Europe(developing only) and Value added (current US$) of St. Lucia?
Provide a short and direct response. 2.19e+11. In the year 2007, what is the difference between the Value added (current US$) of Gabon and Value added (current US$) of Paraguay?
Make the answer very short. -1.26e+09. In the year 2007, what is the difference between the Value added (current US$) in Gabon and Value added (current US$) in St. Lucia?
Your response must be concise. 2.65e+08. In the year 2007, what is the difference between the Value added (current US$) of Paraguay and Value added (current US$) of St. Lucia?
Ensure brevity in your answer.  1.52e+09. In the year 2008, what is the difference between the Value added (current US$) in Europe(developing only) and Value added (current US$) in Gabon?
Offer a very short reply. 2.51e+11. In the year 2008, what is the difference between the Value added (current US$) in Europe(developing only) and Value added (current US$) in Paraguay?
Provide a succinct answer. 2.49e+11. In the year 2008, what is the difference between the Value added (current US$) in Europe(developing only) and Value added (current US$) in St. Lucia?
Offer a terse response. 2.51e+11. In the year 2008, what is the difference between the Value added (current US$) in Gabon and Value added (current US$) in Paraguay?
Ensure brevity in your answer.  -1.77e+09. In the year 2008, what is the difference between the Value added (current US$) in Gabon and Value added (current US$) in St. Lucia?
Offer a very short reply. 3.06e+08. In the year 2008, what is the difference between the Value added (current US$) in Paraguay and Value added (current US$) in St. Lucia?
Ensure brevity in your answer.  2.07e+09. In the year 2009, what is the difference between the Value added (current US$) in Europe(developing only) and Value added (current US$) in Gabon?
Keep it short and to the point. 1.94e+11. In the year 2009, what is the difference between the Value added (current US$) in Europe(developing only) and Value added (current US$) in Paraguay?
Provide a succinct answer. 1.93e+11. In the year 2009, what is the difference between the Value added (current US$) in Europe(developing only) and Value added (current US$) in St. Lucia?
Make the answer very short. 1.94e+11. In the year 2009, what is the difference between the Value added (current US$) of Gabon and Value added (current US$) of Paraguay?
Your answer should be compact. -1.50e+09. In the year 2009, what is the difference between the Value added (current US$) in Gabon and Value added (current US$) in St. Lucia?
Give a very brief answer. 3.07e+08. In the year 2009, what is the difference between the Value added (current US$) in Paraguay and Value added (current US$) in St. Lucia?
Your answer should be very brief. 1.81e+09. In the year 2010, what is the difference between the Value added (current US$) of Europe(developing only) and Value added (current US$) of Gabon?
Ensure brevity in your answer.  2.29e+11. In the year 2010, what is the difference between the Value added (current US$) of Europe(developing only) and Value added (current US$) of Paraguay?
Your answer should be compact. 2.27e+11. In the year 2010, what is the difference between the Value added (current US$) of Europe(developing only) and Value added (current US$) of St. Lucia?
Offer a terse response. 2.29e+11. In the year 2010, what is the difference between the Value added (current US$) of Gabon and Value added (current US$) of Paraguay?
Your response must be concise. -1.96e+09. In the year 2010, what is the difference between the Value added (current US$) of Gabon and Value added (current US$) of St. Lucia?
Offer a very short reply. 2.41e+08. In the year 2010, what is the difference between the Value added (current US$) of Paraguay and Value added (current US$) of St. Lucia?
Give a very brief answer. 2.20e+09. In the year 2011, what is the difference between the Value added (current US$) of Europe(developing only) and Value added (current US$) of Gabon?
Make the answer very short. 2.56e+11. In the year 2011, what is the difference between the Value added (current US$) in Europe(developing only) and Value added (current US$) in Paraguay?
Provide a succinct answer. 2.53e+11. In the year 2011, what is the difference between the Value added (current US$) in Europe(developing only) and Value added (current US$) in St. Lucia?
Give a very brief answer. 2.56e+11. In the year 2011, what is the difference between the Value added (current US$) of Gabon and Value added (current US$) of Paraguay?
Your answer should be very brief. -2.35e+09. In the year 2011, what is the difference between the Value added (current US$) in Gabon and Value added (current US$) in St. Lucia?
Make the answer very short. 3.57e+08. In the year 2011, what is the difference between the Value added (current US$) in Paraguay and Value added (current US$) in St. Lucia?
Your answer should be compact. 2.71e+09. What is the ratio of the Value added (current US$) of Europe(developing only) in 1993 to that in 2005?
Ensure brevity in your answer.  0.56. What is the ratio of the Value added (current US$) in Gabon in 1993 to that in 2005?
Your answer should be very brief. 1.21. What is the ratio of the Value added (current US$) of Paraguay in 1993 to that in 2005?
Your answer should be compact. 0.98. What is the ratio of the Value added (current US$) of St. Lucia in 1993 to that in 2005?
Your answer should be very brief. 0.73. What is the ratio of the Value added (current US$) of Europe(developing only) in 1993 to that in 2006?
Your answer should be compact. 0.48. What is the ratio of the Value added (current US$) of Gabon in 1993 to that in 2006?
Your answer should be very brief. 1.04. What is the ratio of the Value added (current US$) of Paraguay in 1993 to that in 2006?
Make the answer very short. 0.8. What is the ratio of the Value added (current US$) of St. Lucia in 1993 to that in 2006?
Your answer should be compact. 0.68. What is the ratio of the Value added (current US$) in Europe(developing only) in 1993 to that in 2007?
Your response must be concise. 0.39. What is the ratio of the Value added (current US$) in Gabon in 1993 to that in 2007?
Offer a terse response. 0.88. What is the ratio of the Value added (current US$) of Paraguay in 1993 to that in 2007?
Your response must be concise. 0.65. What is the ratio of the Value added (current US$) of St. Lucia in 1993 to that in 2007?
Offer a very short reply. 0.62. What is the ratio of the Value added (current US$) in Europe(developing only) in 1993 to that in 2008?
Your response must be concise. 0.34. What is the ratio of the Value added (current US$) in Gabon in 1993 to that in 2008?
Offer a very short reply. 0.79. What is the ratio of the Value added (current US$) of Paraguay in 1993 to that in 2008?
Offer a very short reply. 0.48. What is the ratio of the Value added (current US$) in St. Lucia in 1993 to that in 2008?
Give a very brief answer. 0.69. What is the ratio of the Value added (current US$) of Europe(developing only) in 1993 to that in 2009?
Your answer should be very brief. 0.44. What is the ratio of the Value added (current US$) in Gabon in 1993 to that in 2009?
Make the answer very short. 0.79. What is the ratio of the Value added (current US$) in Paraguay in 1993 to that in 2009?
Your answer should be compact. 0.55. What is the ratio of the Value added (current US$) in St. Lucia in 1993 to that in 2009?
Your answer should be very brief. 0.77. What is the ratio of the Value added (current US$) in Europe(developing only) in 1993 to that in 2010?
Ensure brevity in your answer.  0.37. What is the ratio of the Value added (current US$) in Gabon in 1993 to that in 2010?
Offer a very short reply. 0.99. What is the ratio of the Value added (current US$) in Paraguay in 1993 to that in 2010?
Your answer should be compact. 0.45. What is the ratio of the Value added (current US$) of St. Lucia in 1993 to that in 2010?
Your answer should be very brief. 0.8. What is the ratio of the Value added (current US$) in Europe(developing only) in 1993 to that in 2011?
Provide a short and direct response. 0.33. What is the ratio of the Value added (current US$) of Gabon in 1993 to that in 2011?
Give a very brief answer. 0.69. What is the ratio of the Value added (current US$) in Paraguay in 1993 to that in 2011?
Provide a succinct answer. 0.37. What is the ratio of the Value added (current US$) of St. Lucia in 1993 to that in 2011?
Ensure brevity in your answer.  0.75. What is the ratio of the Value added (current US$) in Europe(developing only) in 2005 to that in 2006?
Offer a very short reply. 0.85. What is the ratio of the Value added (current US$) of Gabon in 2005 to that in 2006?
Your answer should be compact. 0.86. What is the ratio of the Value added (current US$) in Paraguay in 2005 to that in 2006?
Your answer should be compact. 0.82. What is the ratio of the Value added (current US$) of St. Lucia in 2005 to that in 2006?
Your response must be concise. 0.94. What is the ratio of the Value added (current US$) of Europe(developing only) in 2005 to that in 2007?
Make the answer very short. 0.69. What is the ratio of the Value added (current US$) of Gabon in 2005 to that in 2007?
Offer a terse response. 0.72. What is the ratio of the Value added (current US$) of Paraguay in 2005 to that in 2007?
Offer a very short reply. 0.66. What is the ratio of the Value added (current US$) in St. Lucia in 2005 to that in 2007?
Keep it short and to the point. 0.85. What is the ratio of the Value added (current US$) of Europe(developing only) in 2005 to that in 2008?
Offer a very short reply. 0.6. What is the ratio of the Value added (current US$) in Gabon in 2005 to that in 2008?
Your answer should be very brief. 0.65. What is the ratio of the Value added (current US$) of Paraguay in 2005 to that in 2008?
Offer a terse response. 0.49. What is the ratio of the Value added (current US$) of St. Lucia in 2005 to that in 2008?
Your response must be concise. 0.94. What is the ratio of the Value added (current US$) of Europe(developing only) in 2005 to that in 2009?
Your answer should be compact. 0.78. What is the ratio of the Value added (current US$) in Gabon in 2005 to that in 2009?
Your response must be concise. 0.66. What is the ratio of the Value added (current US$) in Paraguay in 2005 to that in 2009?
Make the answer very short. 0.56. What is the ratio of the Value added (current US$) in St. Lucia in 2005 to that in 2009?
Keep it short and to the point. 1.05. What is the ratio of the Value added (current US$) of Europe(developing only) in 2005 to that in 2010?
Make the answer very short. 0.66. What is the ratio of the Value added (current US$) in Gabon in 2005 to that in 2010?
Offer a very short reply. 0.82. What is the ratio of the Value added (current US$) in Paraguay in 2005 to that in 2010?
Your answer should be compact. 0.46. What is the ratio of the Value added (current US$) in St. Lucia in 2005 to that in 2010?
Provide a short and direct response. 1.1. What is the ratio of the Value added (current US$) in Europe(developing only) in 2005 to that in 2011?
Ensure brevity in your answer.  0.59. What is the ratio of the Value added (current US$) of Gabon in 2005 to that in 2011?
Offer a very short reply. 0.57. What is the ratio of the Value added (current US$) in Paraguay in 2005 to that in 2011?
Provide a short and direct response. 0.38. What is the ratio of the Value added (current US$) in St. Lucia in 2005 to that in 2011?
Provide a succinct answer. 1.03. What is the ratio of the Value added (current US$) of Europe(developing only) in 2006 to that in 2007?
Provide a short and direct response. 0.81. What is the ratio of the Value added (current US$) in Gabon in 2006 to that in 2007?
Your answer should be compact. 0.84. What is the ratio of the Value added (current US$) of Paraguay in 2006 to that in 2007?
Your answer should be very brief. 0.81. What is the ratio of the Value added (current US$) of St. Lucia in 2006 to that in 2007?
Make the answer very short. 0.91. What is the ratio of the Value added (current US$) in Europe(developing only) in 2006 to that in 2008?
Offer a very short reply. 0.71. What is the ratio of the Value added (current US$) of Gabon in 2006 to that in 2008?
Make the answer very short. 0.76. What is the ratio of the Value added (current US$) in Paraguay in 2006 to that in 2008?
Your answer should be compact. 0.6. What is the ratio of the Value added (current US$) in St. Lucia in 2006 to that in 2008?
Your response must be concise. 1.01. What is the ratio of the Value added (current US$) in Europe(developing only) in 2006 to that in 2009?
Offer a very short reply. 0.91. What is the ratio of the Value added (current US$) in Gabon in 2006 to that in 2009?
Offer a terse response. 0.76. What is the ratio of the Value added (current US$) in Paraguay in 2006 to that in 2009?
Make the answer very short. 0.69. What is the ratio of the Value added (current US$) of St. Lucia in 2006 to that in 2009?
Provide a short and direct response. 1.12. What is the ratio of the Value added (current US$) in Europe(developing only) in 2006 to that in 2010?
Offer a terse response. 0.77. What is the ratio of the Value added (current US$) in Gabon in 2006 to that in 2010?
Ensure brevity in your answer.  0.95. What is the ratio of the Value added (current US$) in Paraguay in 2006 to that in 2010?
Your answer should be compact. 0.57. What is the ratio of the Value added (current US$) of St. Lucia in 2006 to that in 2010?
Provide a succinct answer. 1.17. What is the ratio of the Value added (current US$) in Europe(developing only) in 2006 to that in 2011?
Offer a terse response. 0.69. What is the ratio of the Value added (current US$) of Gabon in 2006 to that in 2011?
Provide a short and direct response. 0.67. What is the ratio of the Value added (current US$) of Paraguay in 2006 to that in 2011?
Make the answer very short. 0.46. What is the ratio of the Value added (current US$) of St. Lucia in 2006 to that in 2011?
Your response must be concise. 1.09. What is the ratio of the Value added (current US$) of Europe(developing only) in 2007 to that in 2008?
Offer a terse response. 0.87. What is the ratio of the Value added (current US$) of Gabon in 2007 to that in 2008?
Make the answer very short. 0.9. What is the ratio of the Value added (current US$) of Paraguay in 2007 to that in 2008?
Ensure brevity in your answer.  0.74. What is the ratio of the Value added (current US$) in St. Lucia in 2007 to that in 2008?
Your answer should be very brief. 1.1. What is the ratio of the Value added (current US$) of Europe(developing only) in 2007 to that in 2009?
Give a very brief answer. 1.13. What is the ratio of the Value added (current US$) of Gabon in 2007 to that in 2009?
Keep it short and to the point. 0.9. What is the ratio of the Value added (current US$) of Paraguay in 2007 to that in 2009?
Keep it short and to the point. 0.85. What is the ratio of the Value added (current US$) in St. Lucia in 2007 to that in 2009?
Provide a short and direct response. 1.23. What is the ratio of the Value added (current US$) of Europe(developing only) in 2007 to that in 2010?
Offer a very short reply. 0.96. What is the ratio of the Value added (current US$) of Gabon in 2007 to that in 2010?
Provide a succinct answer. 1.13. What is the ratio of the Value added (current US$) in Paraguay in 2007 to that in 2010?
Your answer should be very brief. 0.7. What is the ratio of the Value added (current US$) of St. Lucia in 2007 to that in 2010?
Offer a very short reply. 1.28. What is the ratio of the Value added (current US$) in Europe(developing only) in 2007 to that in 2011?
Offer a very short reply. 0.86. What is the ratio of the Value added (current US$) in Gabon in 2007 to that in 2011?
Ensure brevity in your answer.  0.79. What is the ratio of the Value added (current US$) of Paraguay in 2007 to that in 2011?
Give a very brief answer. 0.57. What is the ratio of the Value added (current US$) in St. Lucia in 2007 to that in 2011?
Your answer should be very brief. 1.2. What is the ratio of the Value added (current US$) in Europe(developing only) in 2008 to that in 2009?
Provide a succinct answer. 1.29. What is the ratio of the Value added (current US$) in Paraguay in 2008 to that in 2009?
Make the answer very short. 1.15. What is the ratio of the Value added (current US$) of St. Lucia in 2008 to that in 2009?
Your answer should be very brief. 1.11. What is the ratio of the Value added (current US$) of Europe(developing only) in 2008 to that in 2010?
Provide a short and direct response. 1.09. What is the ratio of the Value added (current US$) in Gabon in 2008 to that in 2010?
Your answer should be very brief. 1.26. What is the ratio of the Value added (current US$) of Paraguay in 2008 to that in 2010?
Ensure brevity in your answer.  0.95. What is the ratio of the Value added (current US$) in St. Lucia in 2008 to that in 2010?
Your answer should be compact. 1.16. What is the ratio of the Value added (current US$) in Europe(developing only) in 2008 to that in 2011?
Make the answer very short. 0.98. What is the ratio of the Value added (current US$) in Gabon in 2008 to that in 2011?
Give a very brief answer. 0.88. What is the ratio of the Value added (current US$) in Paraguay in 2008 to that in 2011?
Your answer should be compact. 0.77. What is the ratio of the Value added (current US$) of St. Lucia in 2008 to that in 2011?
Your answer should be compact. 1.09. What is the ratio of the Value added (current US$) in Europe(developing only) in 2009 to that in 2010?
Your answer should be compact. 0.85. What is the ratio of the Value added (current US$) of Gabon in 2009 to that in 2010?
Give a very brief answer. 1.24. What is the ratio of the Value added (current US$) in Paraguay in 2009 to that in 2010?
Make the answer very short. 0.83. What is the ratio of the Value added (current US$) in St. Lucia in 2009 to that in 2010?
Offer a terse response. 1.04. What is the ratio of the Value added (current US$) in Europe(developing only) in 2009 to that in 2011?
Make the answer very short. 0.76. What is the ratio of the Value added (current US$) of Gabon in 2009 to that in 2011?
Make the answer very short. 0.87. What is the ratio of the Value added (current US$) in Paraguay in 2009 to that in 2011?
Offer a terse response. 0.67. What is the ratio of the Value added (current US$) of St. Lucia in 2009 to that in 2011?
Provide a short and direct response. 0.98. What is the ratio of the Value added (current US$) in Europe(developing only) in 2010 to that in 2011?
Your response must be concise. 0.9. What is the ratio of the Value added (current US$) of Gabon in 2010 to that in 2011?
Provide a short and direct response. 0.7. What is the ratio of the Value added (current US$) of Paraguay in 2010 to that in 2011?
Your answer should be compact. 0.81. What is the ratio of the Value added (current US$) in St. Lucia in 2010 to that in 2011?
Give a very brief answer. 0.93. What is the difference between the highest and the second highest Value added (current US$) of Europe(developing only)?
Provide a succinct answer. 5.05e+09. What is the difference between the highest and the second highest Value added (current US$) in Gabon?
Your answer should be very brief. 4.72e+07. What is the difference between the highest and the second highest Value added (current US$) in Paraguay?
Your answer should be compact. 5.10e+08. What is the difference between the highest and the second highest Value added (current US$) in St. Lucia?
Make the answer very short. 4.36e+06. What is the difference between the highest and the lowest Value added (current US$) of Europe(developing only)?
Offer a very short reply. 1.71e+11. What is the difference between the highest and the lowest Value added (current US$) in Gabon?
Your response must be concise. 1.70e+08. What is the difference between the highest and the lowest Value added (current US$) of Paraguay?
Keep it short and to the point. 1.74e+09. What is the difference between the highest and the lowest Value added (current US$) in St. Lucia?
Your answer should be very brief. 1.85e+07. 